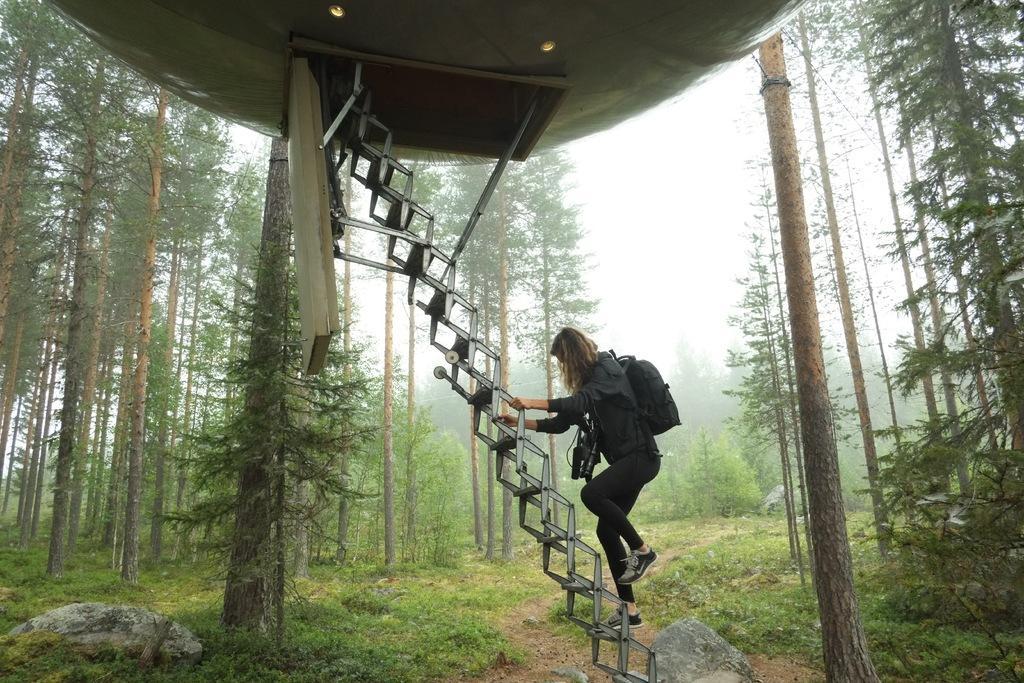Can you describe this image briefly? In the center of the image we can see a ladder, tent, lady wearing camera and bag are there. In the background of the image trees, sky are there. At the bottom of the image ground is there. On the left side of the image rock is there. 